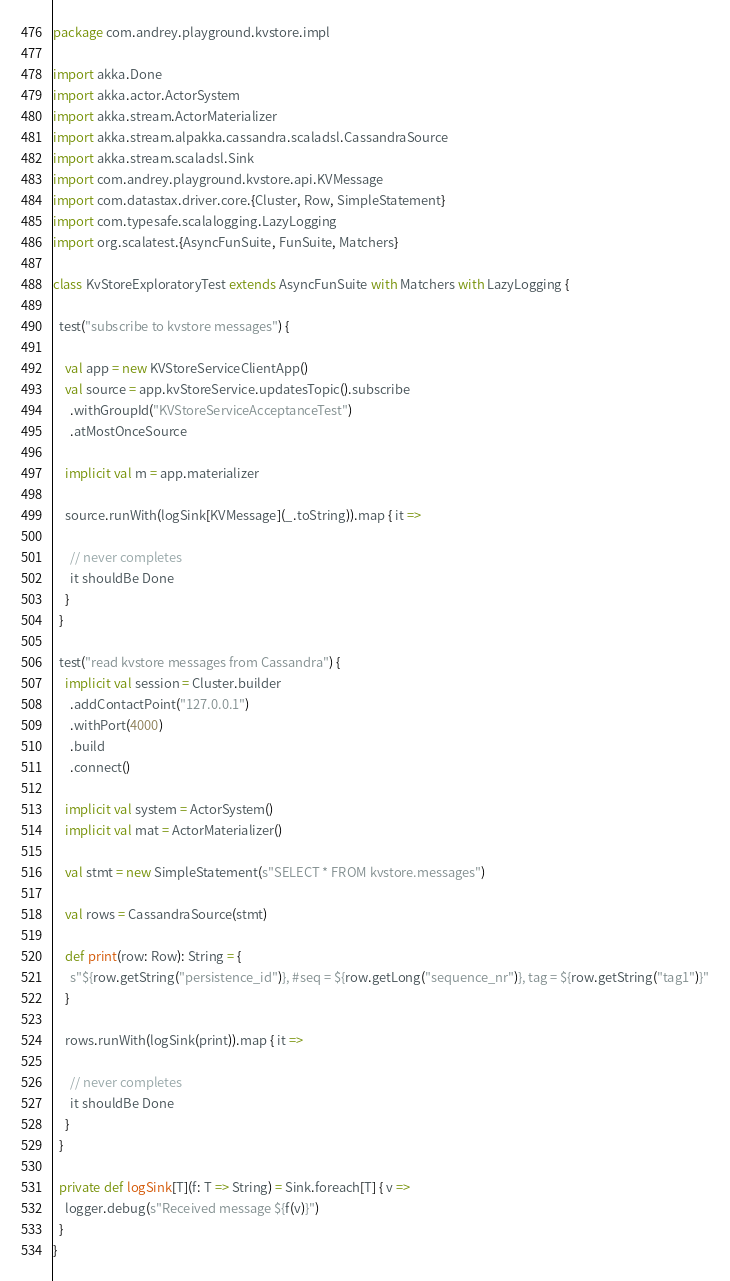<code> <loc_0><loc_0><loc_500><loc_500><_Scala_>package com.andrey.playground.kvstore.impl

import akka.Done
import akka.actor.ActorSystem
import akka.stream.ActorMaterializer
import akka.stream.alpakka.cassandra.scaladsl.CassandraSource
import akka.stream.scaladsl.Sink
import com.andrey.playground.kvstore.api.KVMessage
import com.datastax.driver.core.{Cluster, Row, SimpleStatement}
import com.typesafe.scalalogging.LazyLogging
import org.scalatest.{AsyncFunSuite, FunSuite, Matchers}

class KvStoreExploratoryTest extends AsyncFunSuite with Matchers with LazyLogging {

  test("subscribe to kvstore messages") {

    val app = new KVStoreServiceClientApp()
    val source = app.kvStoreService.updatesTopic().subscribe
      .withGroupId("KVStoreServiceAcceptanceTest")
      .atMostOnceSource

    implicit val m = app.materializer

    source.runWith(logSink[KVMessage](_.toString)).map { it =>

      // never completes
      it shouldBe Done
    }
  }

  test("read kvstore messages from Cassandra") {
    implicit val session = Cluster.builder
      .addContactPoint("127.0.0.1")
      .withPort(4000)
      .build
      .connect()

    implicit val system = ActorSystem()
    implicit val mat = ActorMaterializer()

    val stmt = new SimpleStatement(s"SELECT * FROM kvstore.messages")

    val rows = CassandraSource(stmt)

    def print(row: Row): String = {
      s"${row.getString("persistence_id")}, #seq = ${row.getLong("sequence_nr")}, tag = ${row.getString("tag1")}"
    }

    rows.runWith(logSink(print)).map { it =>

      // never completes
      it shouldBe Done
    }
  }

  private def logSink[T](f: T => String) = Sink.foreach[T] { v =>
    logger.debug(s"Received message ${f(v)}")
  }
}
</code> 